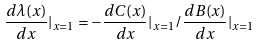Convert formula to latex. <formula><loc_0><loc_0><loc_500><loc_500>\frac { d \lambda ( x ) } { d x } | _ { x = 1 } = { - \frac { d C ( x ) } { d x } | _ { x = 1 } } / { \frac { d B ( x ) } { d x } | _ { x = 1 } }</formula> 